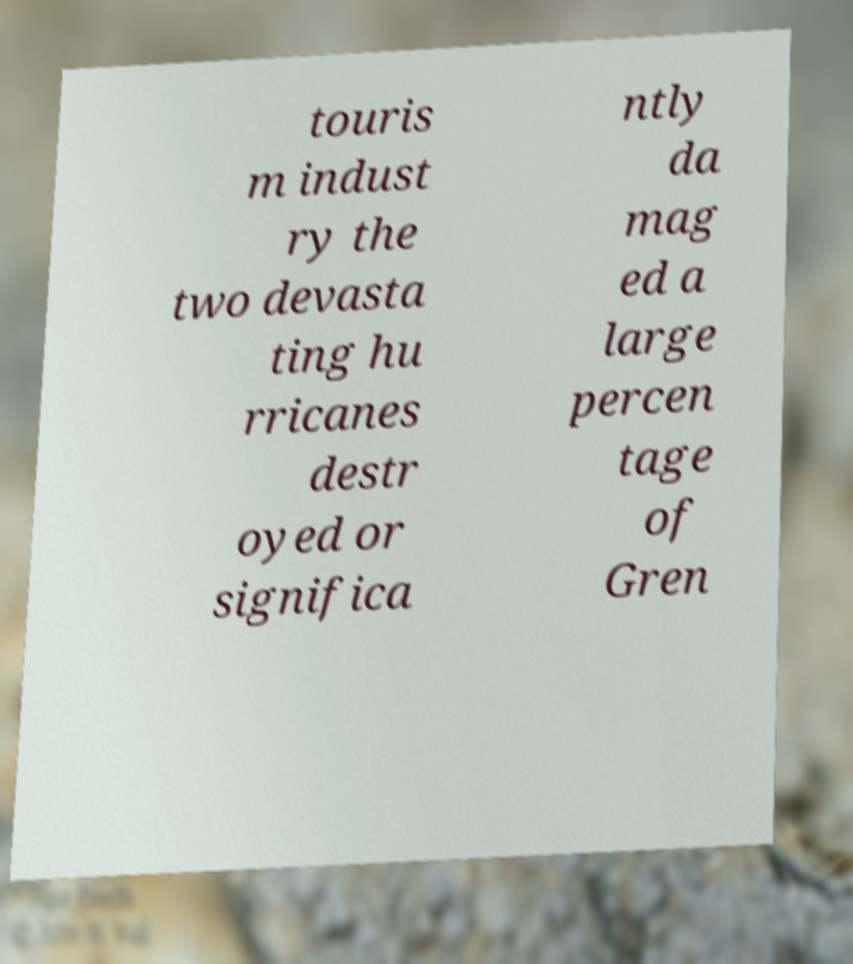What messages or text are displayed in this image? I need them in a readable, typed format. touris m indust ry the two devasta ting hu rricanes destr oyed or significa ntly da mag ed a large percen tage of Gren 